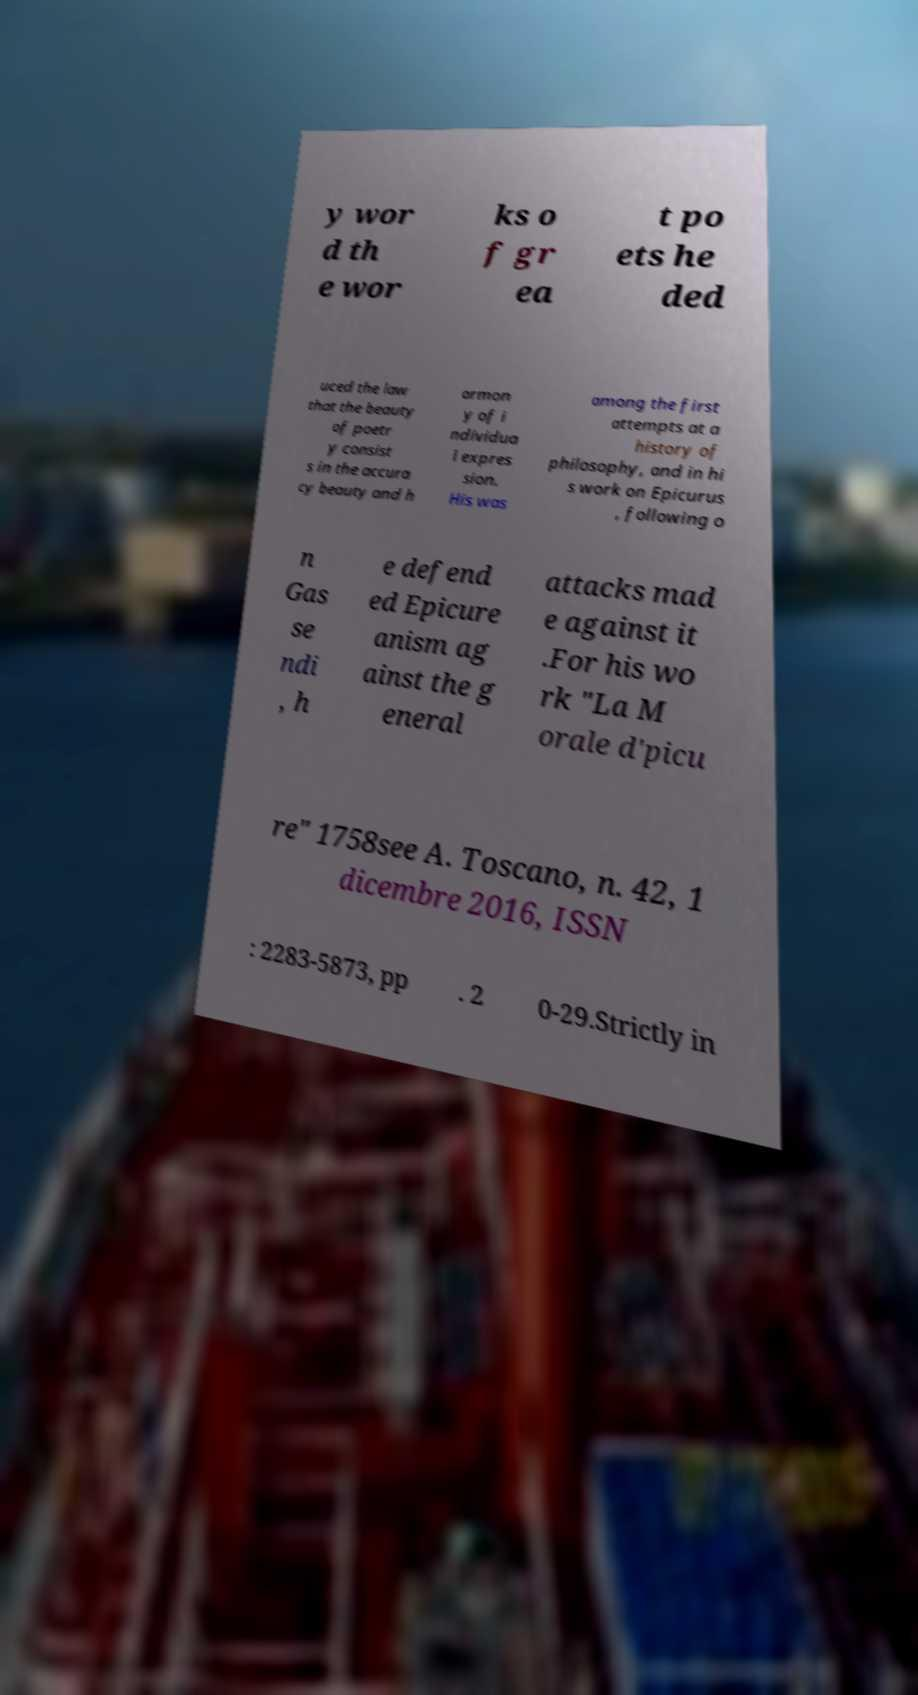Could you extract and type out the text from this image? y wor d th e wor ks o f gr ea t po ets he ded uced the law that the beauty of poetr y consist s in the accura cy beauty and h armon y of i ndividua l expres sion. His was among the first attempts at a history of philosophy, and in hi s work on Epicurus , following o n Gas se ndi , h e defend ed Epicure anism ag ainst the g eneral attacks mad e against it .For his wo rk "La M orale d'picu re" 1758see A. Toscano, n. 42, 1 dicembre 2016, ISSN : 2283-5873, pp . 2 0-29.Strictly in 